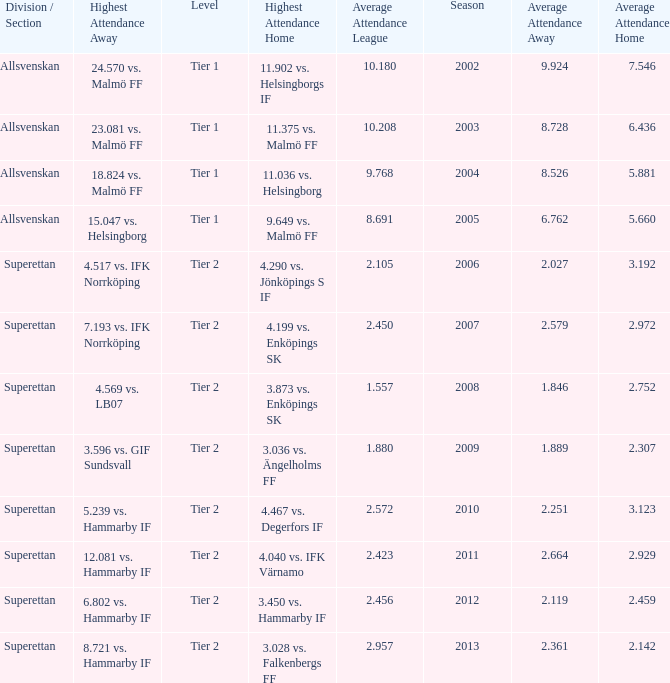How many season have an average attendance league of 2.456? 2012.0. 